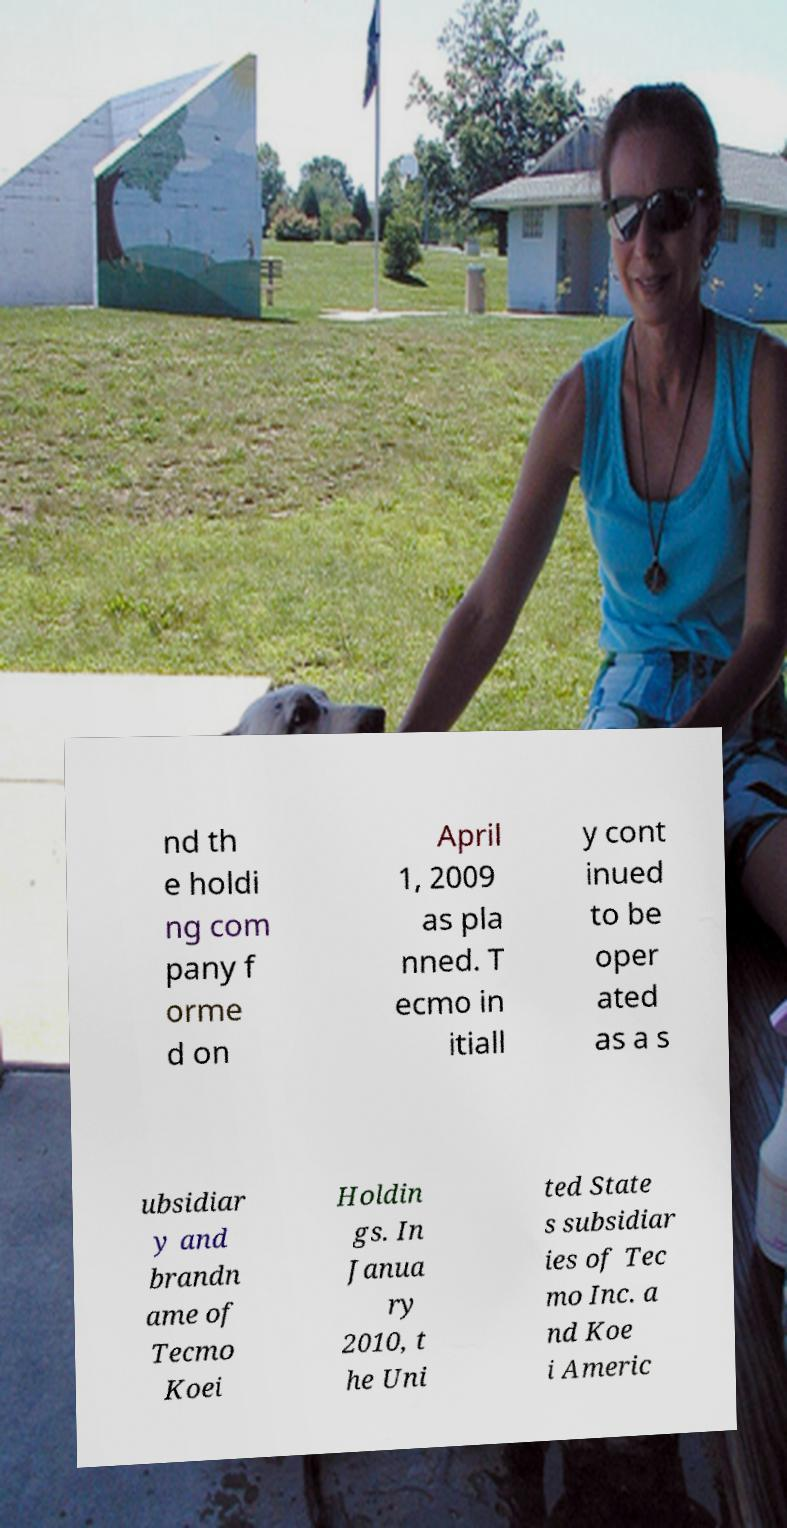I need the written content from this picture converted into text. Can you do that? nd th e holdi ng com pany f orme d on April 1, 2009 as pla nned. T ecmo in itiall y cont inued to be oper ated as a s ubsidiar y and brandn ame of Tecmo Koei Holdin gs. In Janua ry 2010, t he Uni ted State s subsidiar ies of Tec mo Inc. a nd Koe i Americ 